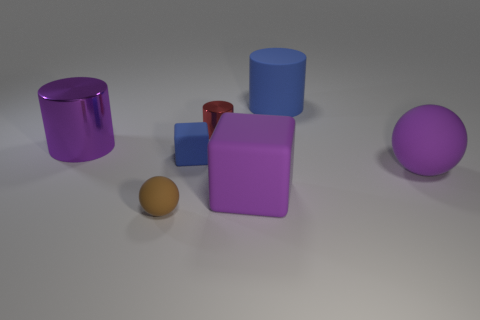There is a tiny blue matte thing; what shape is it?
Offer a terse response. Cube. What shape is the large purple rubber object that is right of the large cylinder right of the tiny red metal cylinder?
Your answer should be very brief. Sphere. Do the large purple block that is right of the tiny matte cube and the small block have the same material?
Your response must be concise. Yes. How many blue objects are either large rubber objects or large things?
Your response must be concise. 1. Is there a thing of the same color as the large block?
Offer a very short reply. Yes. Is there a large purple cylinder that has the same material as the brown ball?
Provide a short and direct response. No. What shape is the object that is right of the small red metal cylinder and behind the large purple metal object?
Offer a very short reply. Cylinder. How many small things are yellow metallic cylinders or brown objects?
Make the answer very short. 1. What material is the purple cylinder?
Make the answer very short. Metal. What number of other things are there of the same shape as the tiny brown matte object?
Ensure brevity in your answer.  1. 